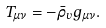Convert formula to latex. <formula><loc_0><loc_0><loc_500><loc_500>T _ { \mu \nu } = - \bar { \rho } _ { v } g _ { \mu \nu } .</formula> 